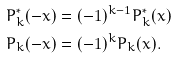Convert formula to latex. <formula><loc_0><loc_0><loc_500><loc_500>P _ { k } ^ { * } ( - x ) & = ( - 1 ) ^ { k - 1 } P _ { k } ^ { * } ( x ) \\ P _ { k } ( - x ) & = ( - 1 ) ^ { k } P _ { k } ( x ) .</formula> 